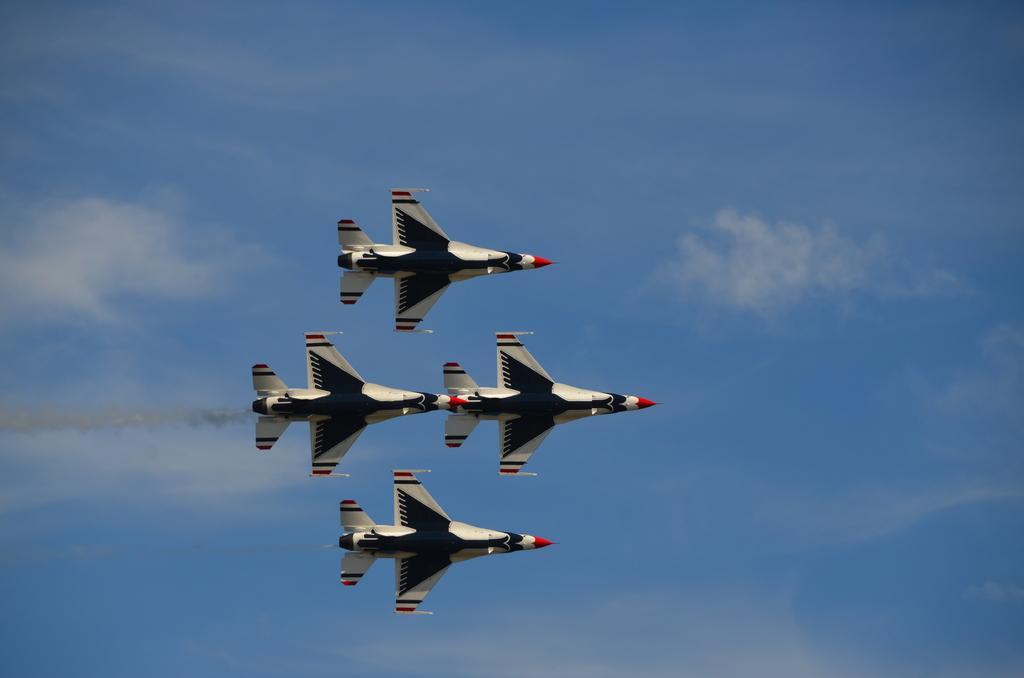How would you summarize this image in a sentence or two? In this image I can see few aircraft's and they are in white and black color. In the background I can see the sky in blue and white color. 